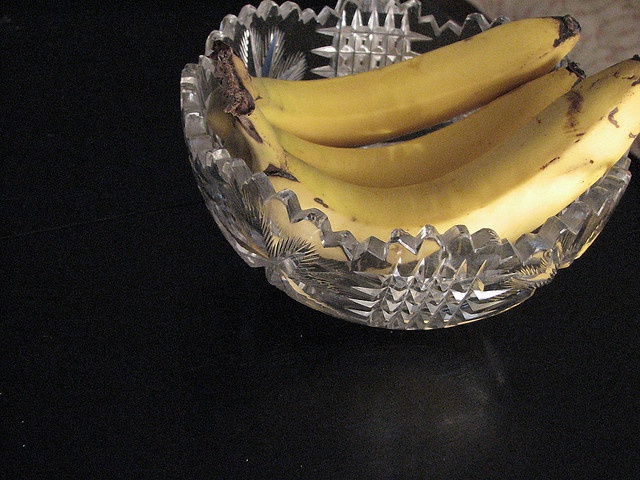Describe the objects in this image and their specific colors. I can see a banana in black, tan, and olive tones in this image. 